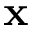Convert formula to latex. <formula><loc_0><loc_0><loc_500><loc_500>x</formula> 